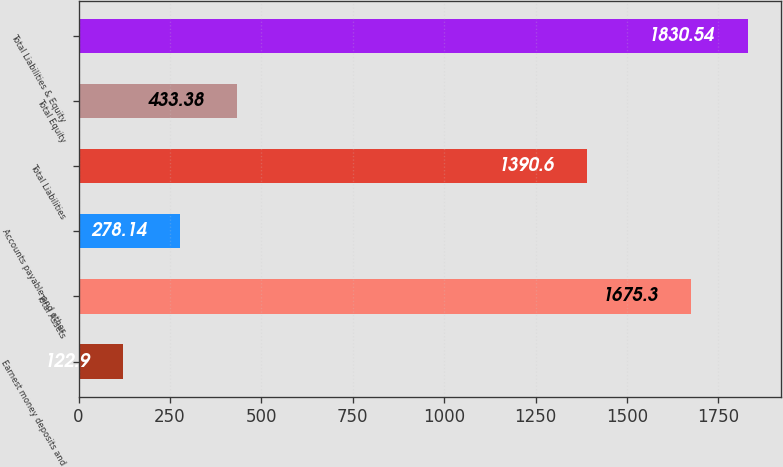Convert chart to OTSL. <chart><loc_0><loc_0><loc_500><loc_500><bar_chart><fcel>Earnest money deposits and<fcel>Total Assets<fcel>Accounts payable and other<fcel>Total Liabilities<fcel>Total Equity<fcel>Total Liabilities & Equity<nl><fcel>122.9<fcel>1675.3<fcel>278.14<fcel>1390.6<fcel>433.38<fcel>1830.54<nl></chart> 